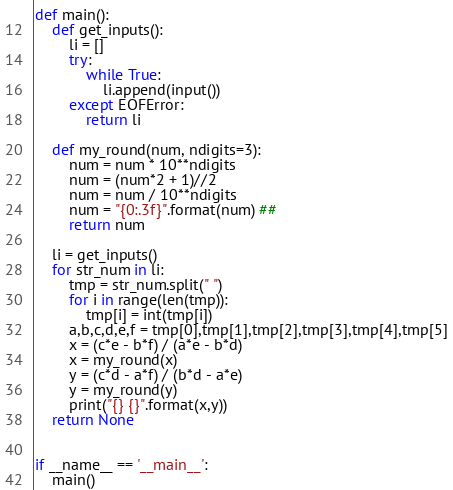Convert code to text. <code><loc_0><loc_0><loc_500><loc_500><_Python_>def main():
    def get_inputs():
        li = []
        try:
            while True:
                li.append(input())
        except EOFError:
            return li

    def my_round(num, ndigits=3):
        num = num * 10**ndigits
        num = (num*2 + 1)//2
        num = num / 10**ndigits
        num = "{0:.3f}".format(num) ##
        return num

    li = get_inputs()
    for str_num in li:
        tmp = str_num.split(" ")
        for i in range(len(tmp)):
            tmp[i] = int(tmp[i])
        a,b,c,d,e,f = tmp[0],tmp[1],tmp[2],tmp[3],tmp[4],tmp[5]
        x = (c*e - b*f) / (a*e - b*d)
        x = my_round(x)
        y = (c*d - a*f) / (b*d - a*e)
        y = my_round(y)
        print("{} {}".format(x,y))
    return None


if __name__ == '__main__':
    main()</code> 